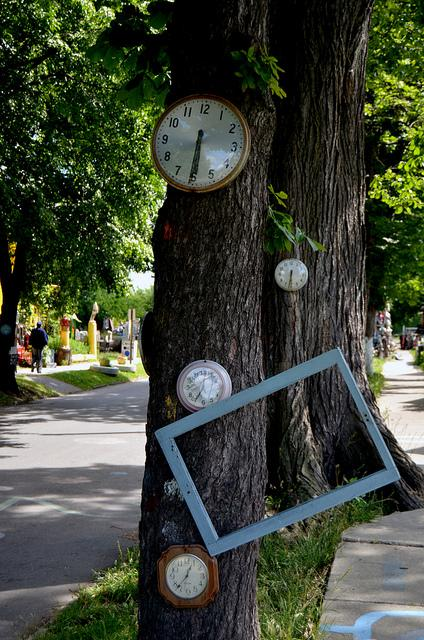What time can be seen on the highest clock? Please explain your reasoning. six thirty. Both hands of the clock are pointing at the six. 